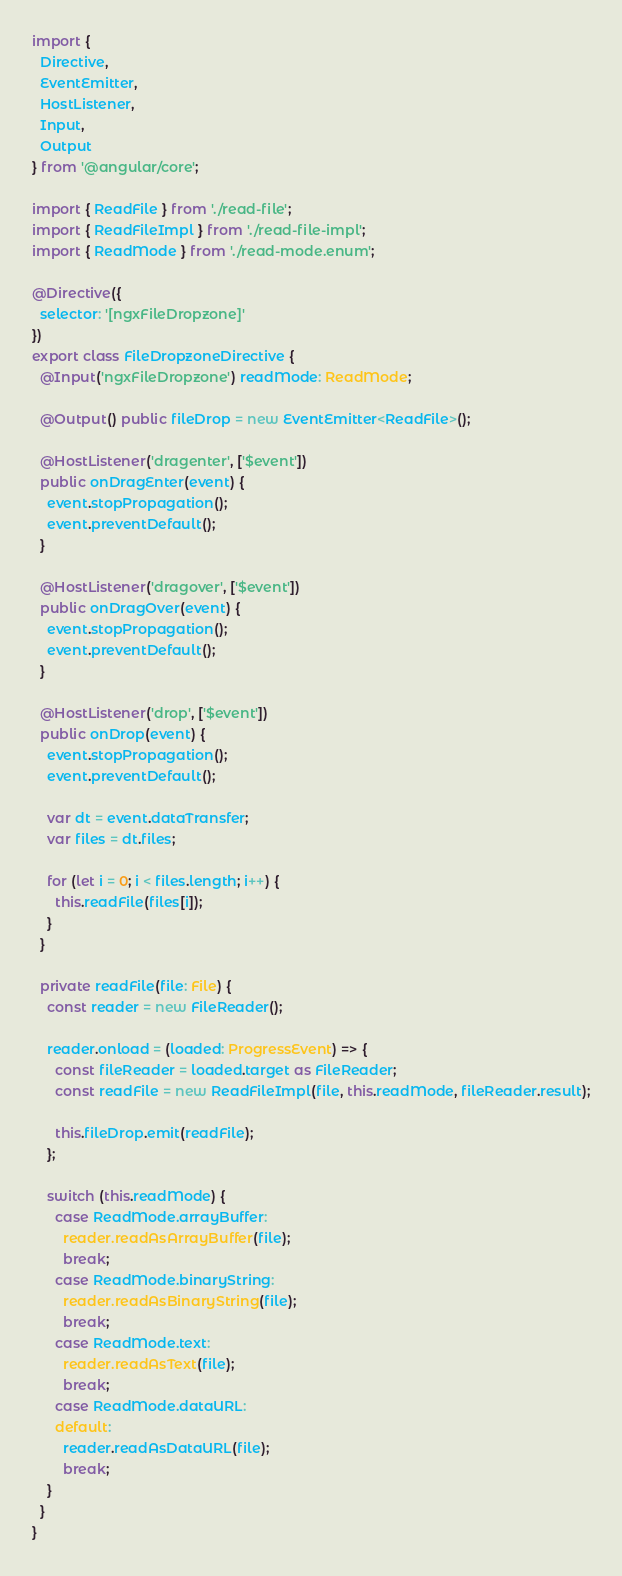Convert code to text. <code><loc_0><loc_0><loc_500><loc_500><_TypeScript_>import {
  Directive,
  EventEmitter,
  HostListener,
  Input,
  Output
} from '@angular/core';

import { ReadFile } from './read-file';
import { ReadFileImpl } from './read-file-impl';
import { ReadMode } from './read-mode.enum';

@Directive({
  selector: '[ngxFileDropzone]'
})
export class FileDropzoneDirective {
  @Input('ngxFileDropzone') readMode: ReadMode;

  @Output() public fileDrop = new EventEmitter<ReadFile>();

  @HostListener('dragenter', ['$event'])
  public onDragEnter(event) {
    event.stopPropagation();
    event.preventDefault();
  }

  @HostListener('dragover', ['$event'])
  public onDragOver(event) {
    event.stopPropagation();
    event.preventDefault();
  }

  @HostListener('drop', ['$event'])
  public onDrop(event) {
    event.stopPropagation();
    event.preventDefault();

    var dt = event.dataTransfer;
    var files = dt.files;

    for (let i = 0; i < files.length; i++) {
      this.readFile(files[i]);
    }
  }

  private readFile(file: File) {
    const reader = new FileReader();

    reader.onload = (loaded: ProgressEvent) => {
      const fileReader = loaded.target as FileReader;
      const readFile = new ReadFileImpl(file, this.readMode, fileReader.result);

      this.fileDrop.emit(readFile);
    };

    switch (this.readMode) {
      case ReadMode.arrayBuffer:
        reader.readAsArrayBuffer(file);
        break;
      case ReadMode.binaryString:
        reader.readAsBinaryString(file);
        break;
      case ReadMode.text:
        reader.readAsText(file);
        break;
      case ReadMode.dataURL:
      default:
        reader.readAsDataURL(file);
        break;
    }
  }
}
</code> 